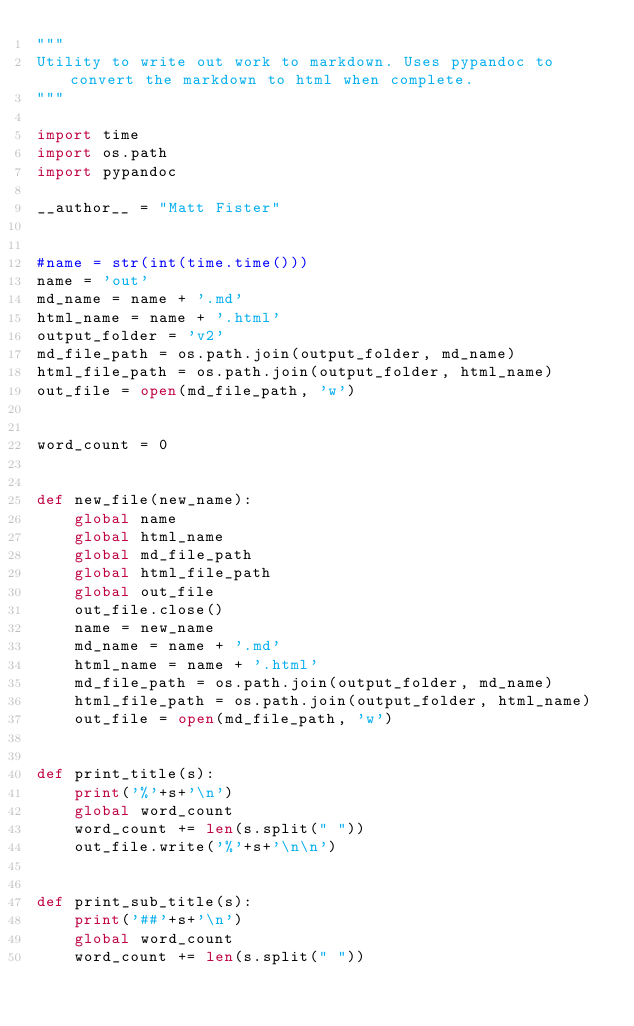<code> <loc_0><loc_0><loc_500><loc_500><_Python_>"""
Utility to write out work to markdown. Uses pypandoc to convert the markdown to html when complete.
"""

import time
import os.path
import pypandoc

__author__ = "Matt Fister"


#name = str(int(time.time()))
name = 'out'
md_name = name + '.md'
html_name = name + '.html'
output_folder = 'v2'
md_file_path = os.path.join(output_folder, md_name)
html_file_path = os.path.join(output_folder, html_name)
out_file = open(md_file_path, 'w')


word_count = 0


def new_file(new_name):
    global name
    global html_name
    global md_file_path
    global html_file_path
    global out_file
    out_file.close()
    name = new_name
    md_name = name + '.md'
    html_name = name + '.html'
    md_file_path = os.path.join(output_folder, md_name)
    html_file_path = os.path.join(output_folder, html_name)
    out_file = open(md_file_path, 'w')


def print_title(s):
    print('%'+s+'\n')
    global word_count
    word_count += len(s.split(" "))
    out_file.write('%'+s+'\n\n')


def print_sub_title(s):
    print('##'+s+'\n')
    global word_count
    word_count += len(s.split(" "))</code> 